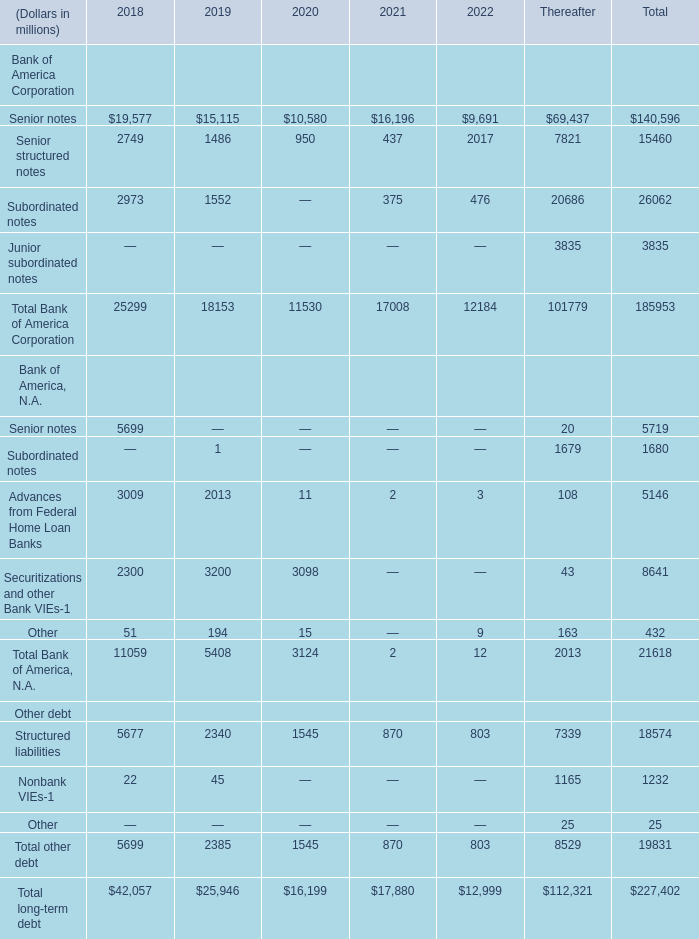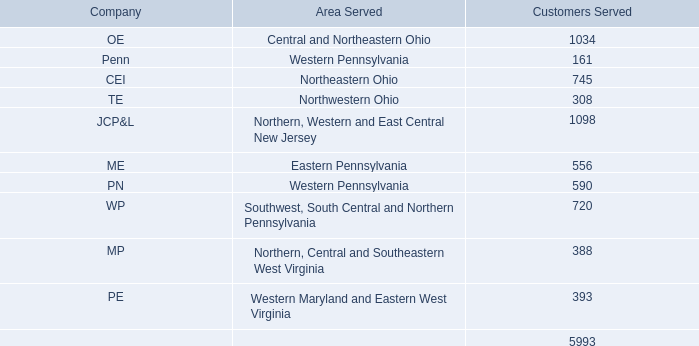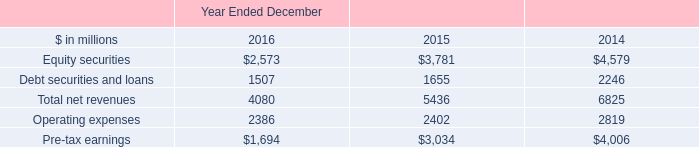How many element exceed the average of Senior notes in 2018? 
Answer: 1. 